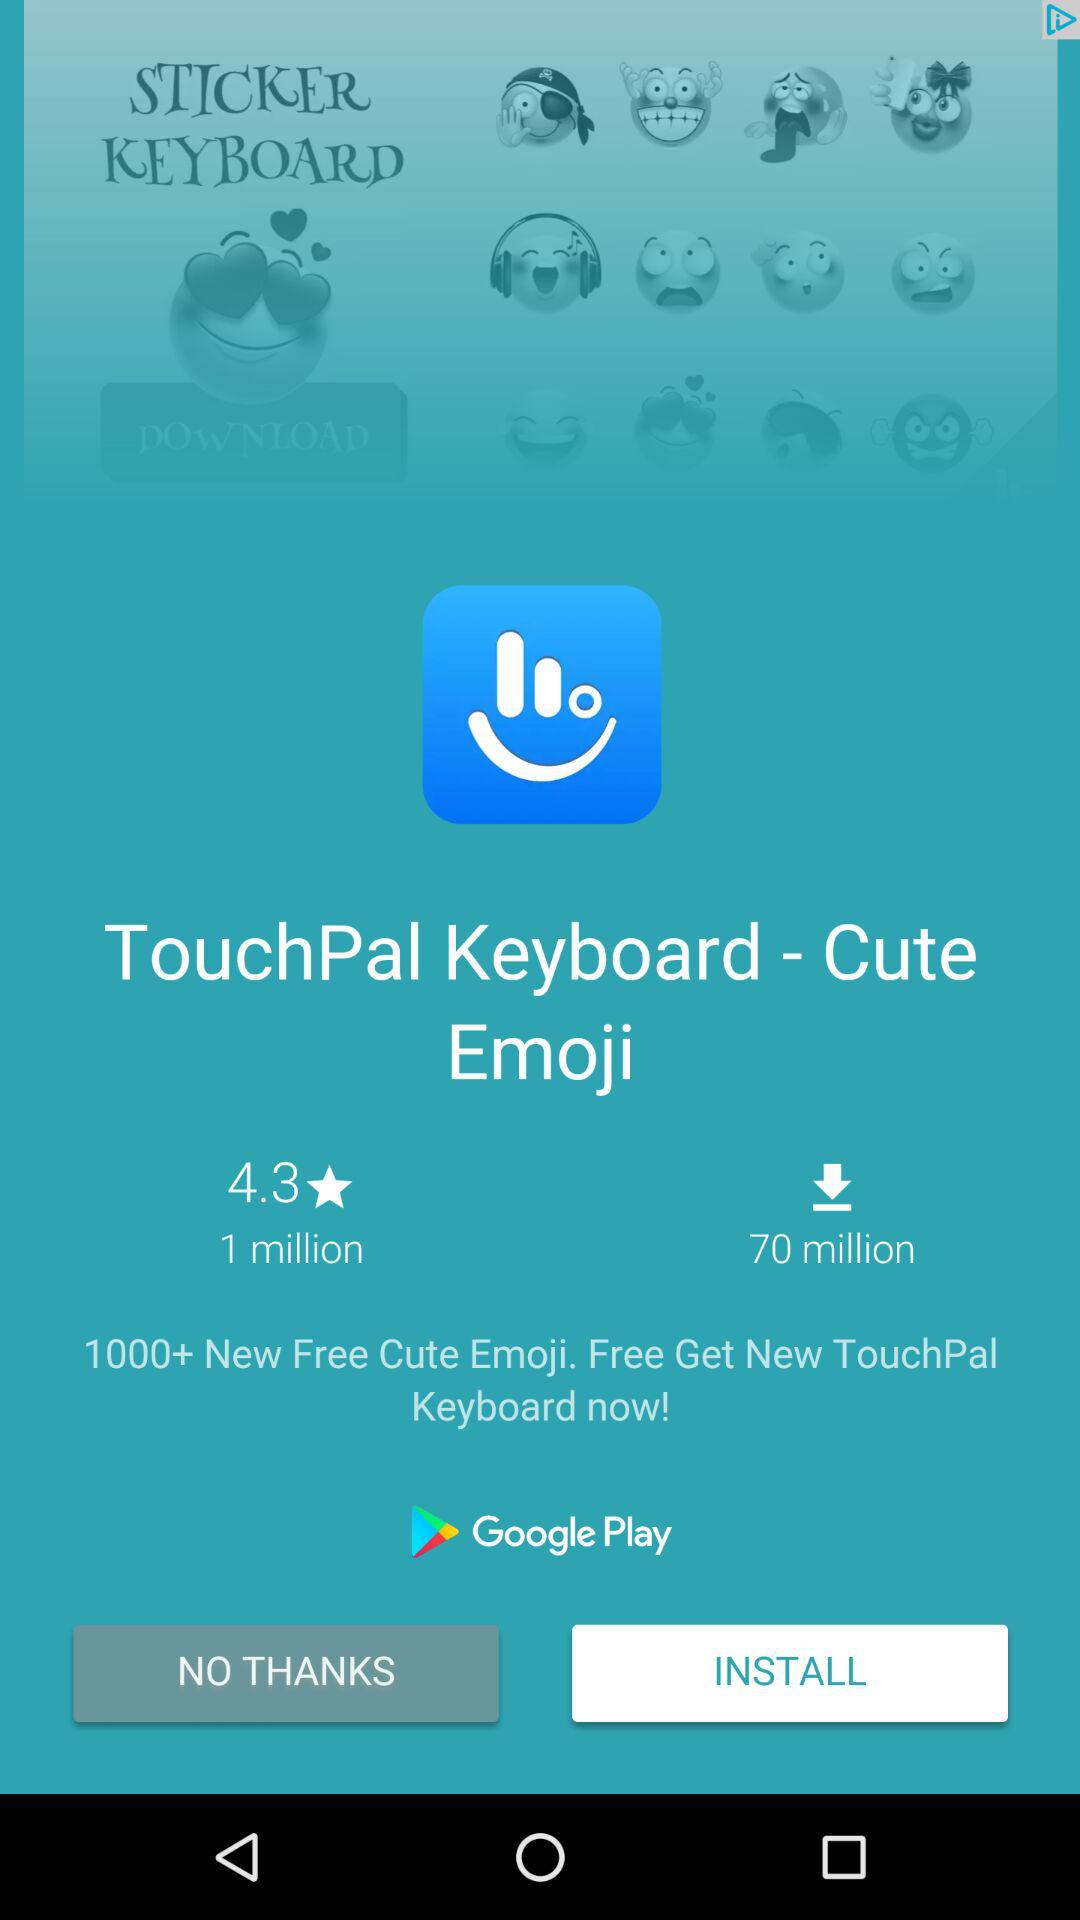What is the name of the application? The name of the application is "TouchPal Keyboard - Cute Emoji". 